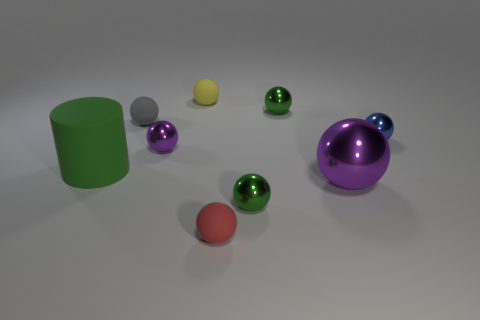Subtract all small red spheres. How many spheres are left? 7 Subtract all green spheres. How many spheres are left? 6 Subtract all cylinders. How many objects are left? 8 Subtract 6 spheres. How many spheres are left? 2 Add 1 tiny purple things. How many objects exist? 10 Subtract all metal balls. Subtract all small red rubber things. How many objects are left? 3 Add 3 rubber cylinders. How many rubber cylinders are left? 4 Add 2 tiny yellow matte cylinders. How many tiny yellow matte cylinders exist? 2 Subtract 0 purple blocks. How many objects are left? 9 Subtract all gray cylinders. Subtract all yellow balls. How many cylinders are left? 1 